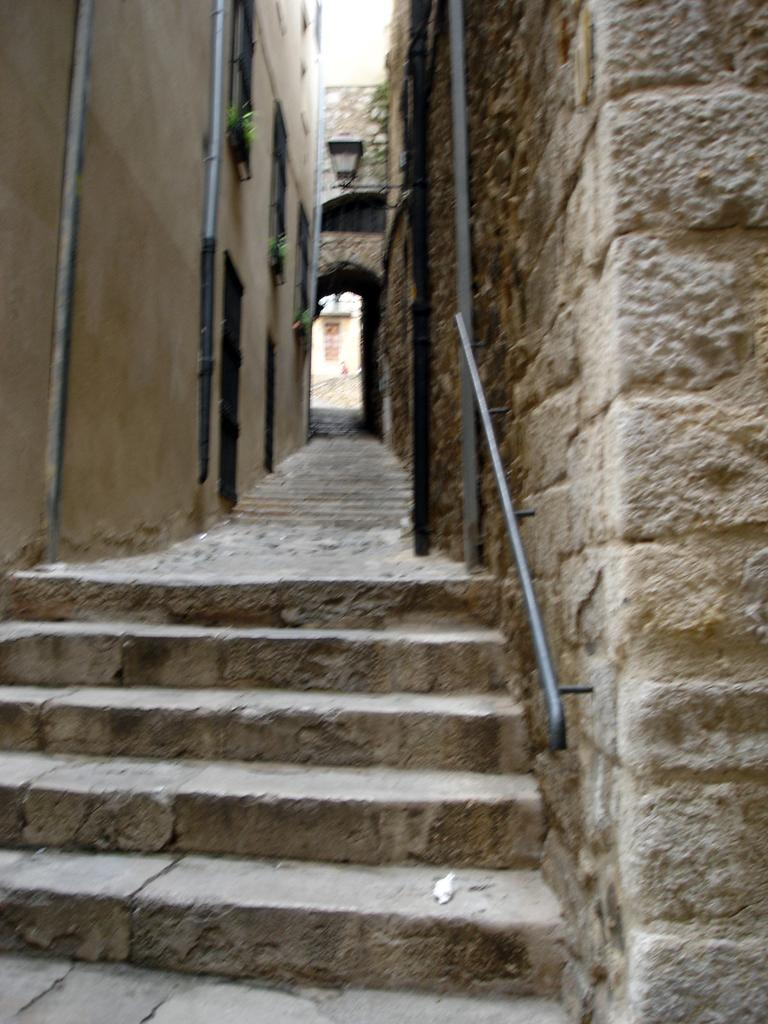What type of material is used to construct the stair in the image? The stair in the image is made up of stone. Where is the stair located in relation to the image? The stair is on the left side of the image. What can be seen on the right side of the image? There are two poles on the right side of the image. What is the main feature in the middle of the image? There is a narrow street in the middle of the image. What type of lace can be seen decorating the poles in the image? There is no lace present on the poles in the image. How many snakes are slithering on the stone stair in the image? There are no snakes present on the stone stair in the image. 